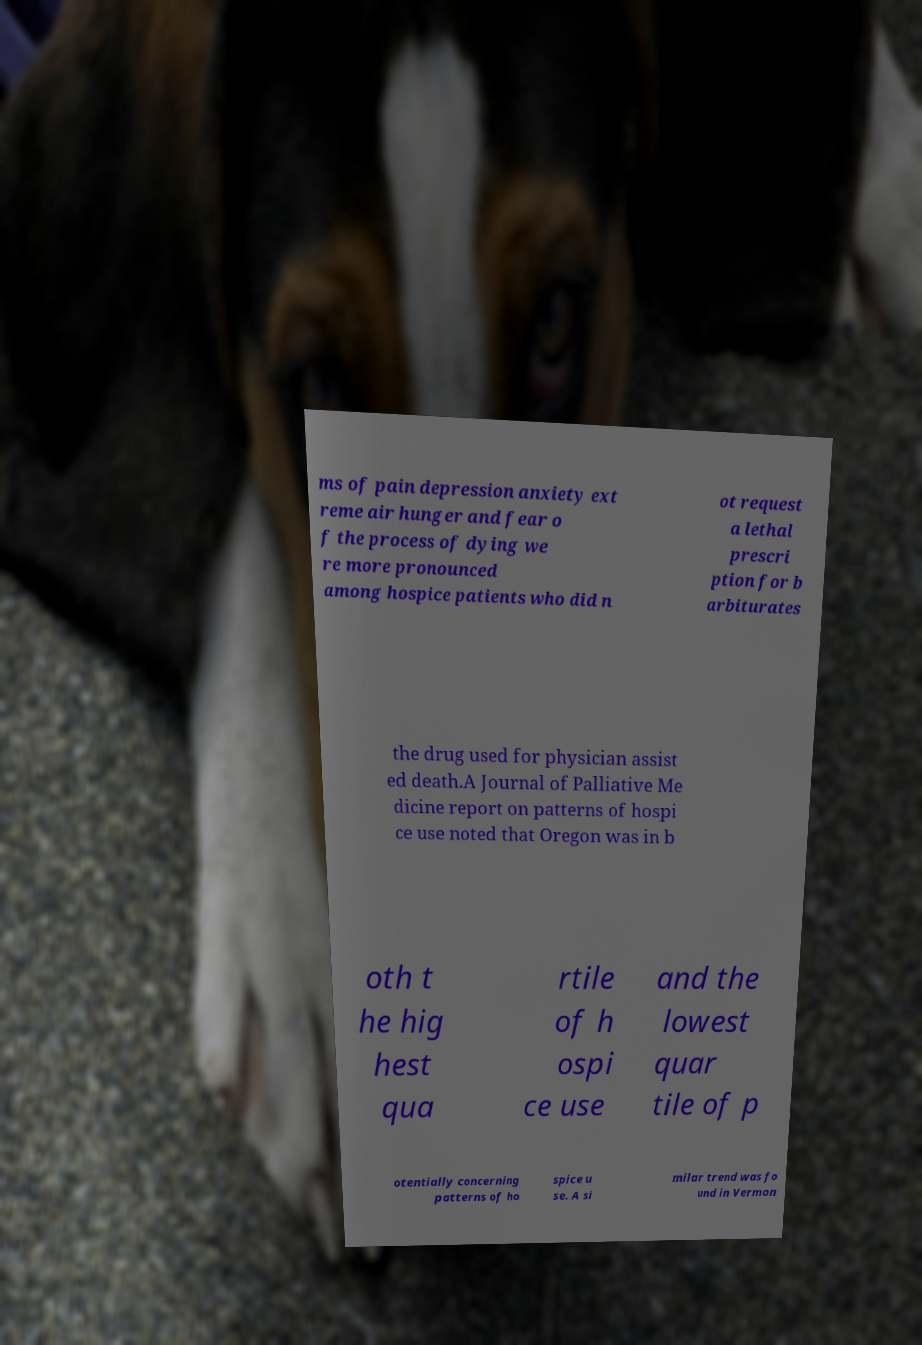For documentation purposes, I need the text within this image transcribed. Could you provide that? ms of pain depression anxiety ext reme air hunger and fear o f the process of dying we re more pronounced among hospice patients who did n ot request a lethal prescri ption for b arbiturates the drug used for physician assist ed death.A Journal of Palliative Me dicine report on patterns of hospi ce use noted that Oregon was in b oth t he hig hest qua rtile of h ospi ce use and the lowest quar tile of p otentially concerning patterns of ho spice u se. A si milar trend was fo und in Vermon 